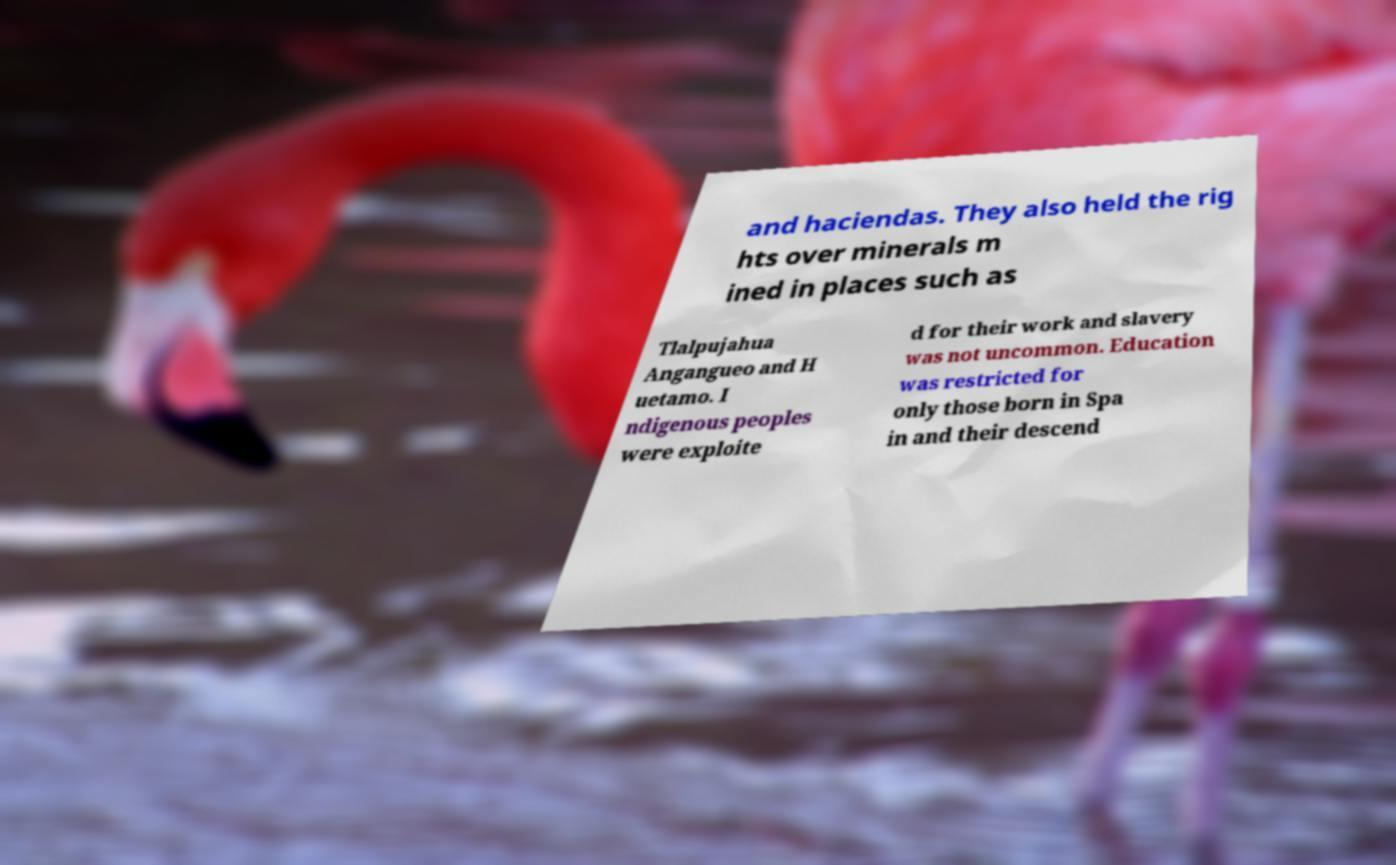Please identify and transcribe the text found in this image. and haciendas. They also held the rig hts over minerals m ined in places such as Tlalpujahua Angangueo and H uetamo. I ndigenous peoples were exploite d for their work and slavery was not uncommon. Education was restricted for only those born in Spa in and their descend 